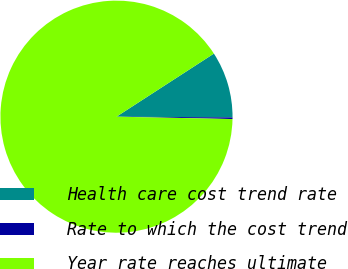Convert chart to OTSL. <chart><loc_0><loc_0><loc_500><loc_500><pie_chart><fcel>Health care cost trend rate<fcel>Rate to which the cost trend<fcel>Year rate reaches ultimate<nl><fcel>9.25%<fcel>0.22%<fcel>90.52%<nl></chart> 